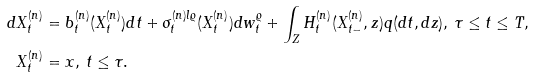Convert formula to latex. <formula><loc_0><loc_0><loc_500><loc_500>d X ^ { ( n ) } _ { t } & = b ^ { ( n ) } _ { t } ( X ^ { ( n ) } _ { t } ) d t + \sigma ^ { ( n ) l \varrho } _ { t } ( X ^ { ( n ) } _ { t } ) d w ^ { \varrho } _ { t } + \int _ { Z } H ^ { ( n ) } _ { t } ( X ^ { ( n ) } _ { t - } , z ) q ( d t , d z ) , \, \tau \leq t \leq T , \\ X ^ { ( n ) } _ { t } & = x , \, t \leq \tau .</formula> 